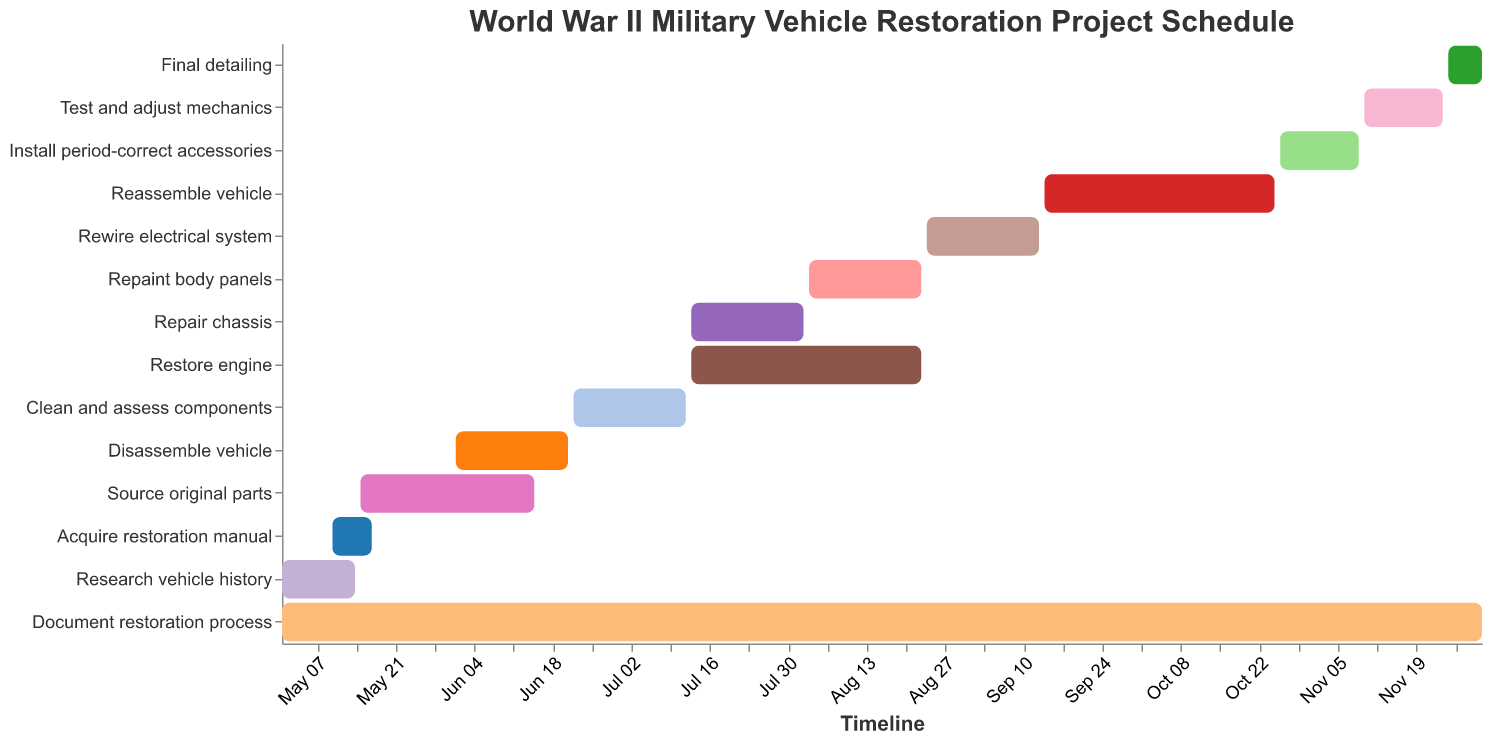What is the title of the Gantt chart? The title is located at the top of the chart in a larger font and usually provides an overview of the chart's purpose. In this case, it's "World War II Military Vehicle Restoration Project Schedule".
Answer: World War II Military Vehicle Restoration Project Schedule Which task has the longest duration? To find the longest duration, check the "Duration" values for each task. "Document restoration process" has the longest duration of 214 days.
Answer: Document restoration process When does the task "Repaint body panels" start and end? Look at the "Start Date" and "End Date" columns for the task "Repaint body panels". It starts on 2023-08-03 and ends on 2023-08-23.
Answer: Starts: 2023-08-03, Ends: 2023-08-23 Which tasks are scheduled to start on the same week? Compare the start dates of tasks to identify those that fall within the same 7-day period. "Repair chassis" and "Restore engine" both start on 2023-07-13.
Answer: Repair chassis, Restore engine What is the total duration of the project? The project starts with "Research vehicle history" on 2023-05-01 and ends with "Final detailing" on 2023-12-01. The total duration is from May 1 to December 1, which is 214 days.
Answer: 214 days Which tasks overlap with the "Disassemble vehicle" task? The "Disassemble vehicle" task runs from 2023-06-01 to 2023-06-21. Check which tasks have start or end dates within this period. "Source original parts" and "Clean and assess components" overlap with "Disassemble vehicle".
Answer: Source original parts, Clean and assess components What tasks are scheduled to occur in August? Identify tasks that have a start or end date within August. These tasks are "Restore engine", "Repaint body panels", and "Rewire electrical system".
Answer: Restore engine, Repaint body panels, Rewire electrical system How many tasks have a duration of exactly 20 days? Check the duration values and count how many tasks have a duration of 20 days. There are four such tasks: "Clean and assess components", "Repair chassis", "Repaint body panels", and "Rewire electrical system".
Answer: 4 tasks Which tasks proceed directly after "Restore engine"? "Restore engine" ends on 2023-08-23. The task starting immediately after is "Rewire electrical system", which starts on 2023-08-24.
Answer: Rewire electrical system 